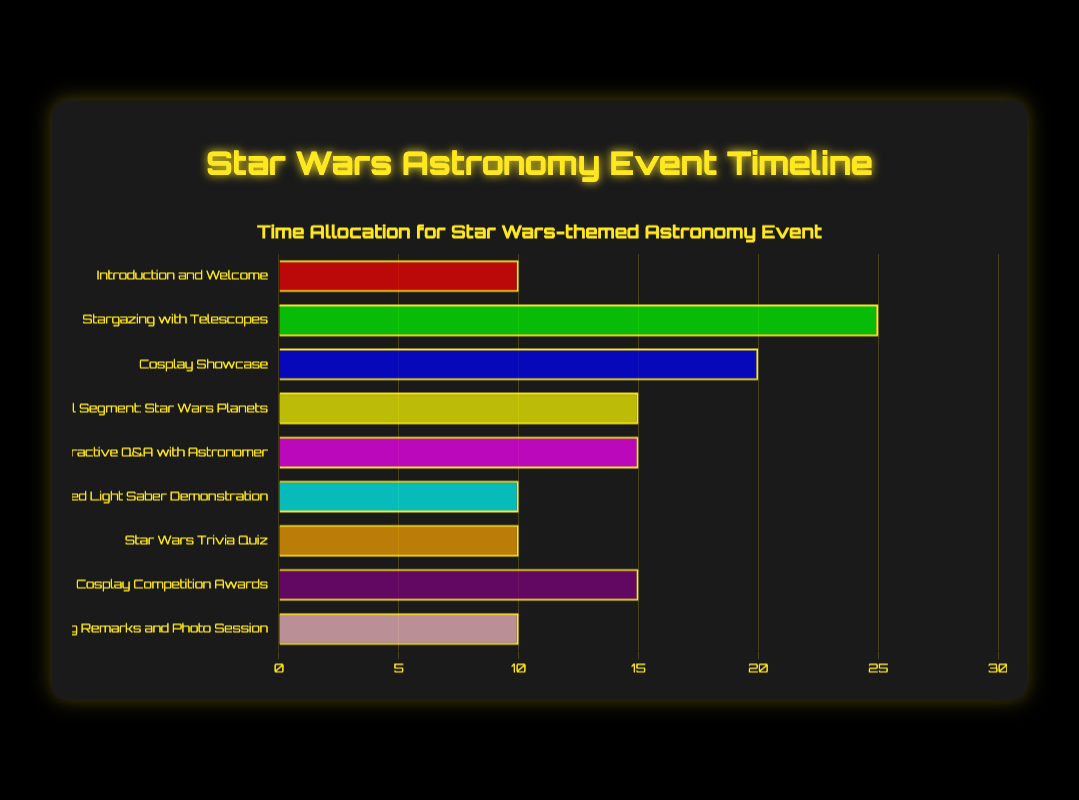What is the longest activity in the event? By examining the bar chart and comparing the lengths of the bars representing each activity's duration, the longest bar represents the "Stargazing with Telescopes" activity.
Answer: Stargazing with Telescopes How much time in total is allocated to Cosplay-related activities? There are two cosplay-related activities: "Cosplay Showcase" (20 minutes) and "Cosplay Competition Awards" (15 minutes). Summing these up gives us 20 + 15 = 35 minutes.
Answer: 35 minutes Which activity has the same duration as the "Educational Segment: Star Wars Planets"? Looking at the chart, the "Interactive Q&A with Astronomer" and "Cosplay Competition Awards" activities both have a duration of 15 minutes, the same as the "Educational Segment: Star Wars Planets".
Answer: Interactive Q&A with Astronomer and Cosplay Competition Awards What is the total duration of the event? We add the durations of all activities: 10 + 25 + 20 + 15 + 15 + 10 + 10 + 15 + 10 = 130 minutes.
Answer: 130 minutes Which activities are shorter than "Cosplay Showcase"? The "Cosplay Showcase" duration is 20 minutes. The activities shorter than 20 minutes are: "Introduction and Welcome" (10 minutes), "Educational Segment: Star Wars Planets" (15 minutes), "Interactive Q&A with Astronomer" (15 minutes), "Themed Light Saber Demonstration" (10 minutes), "Star Wars Trivia Quiz" (10 minutes), and "Closing Remarks and Photo Session" (10 minutes).
Answer: Introduction and Welcome, Educational Segment: Star Wars Planets, Interactive Q&A with Astronomer, Themed Light Saber Demonstration, Star Wars Trivia Quiz, Closing Remarks and Photo Session How does the time spent on the "Interactive Q&A with Astronomer" compare to the "Star Wars Trivia Quiz"? Both activities have the same duration of 15 minutes.
Answer: Equal What is the average duration of all activities? Sum the durations: 10 + 25 + 20 + 15 + 15 + 10 + 10 + 15 + 10 = 130 minutes. There are 9 activities, so the average is 130 / 9 ≈ 14.44 minutes.
Answer: 14.44 minutes 